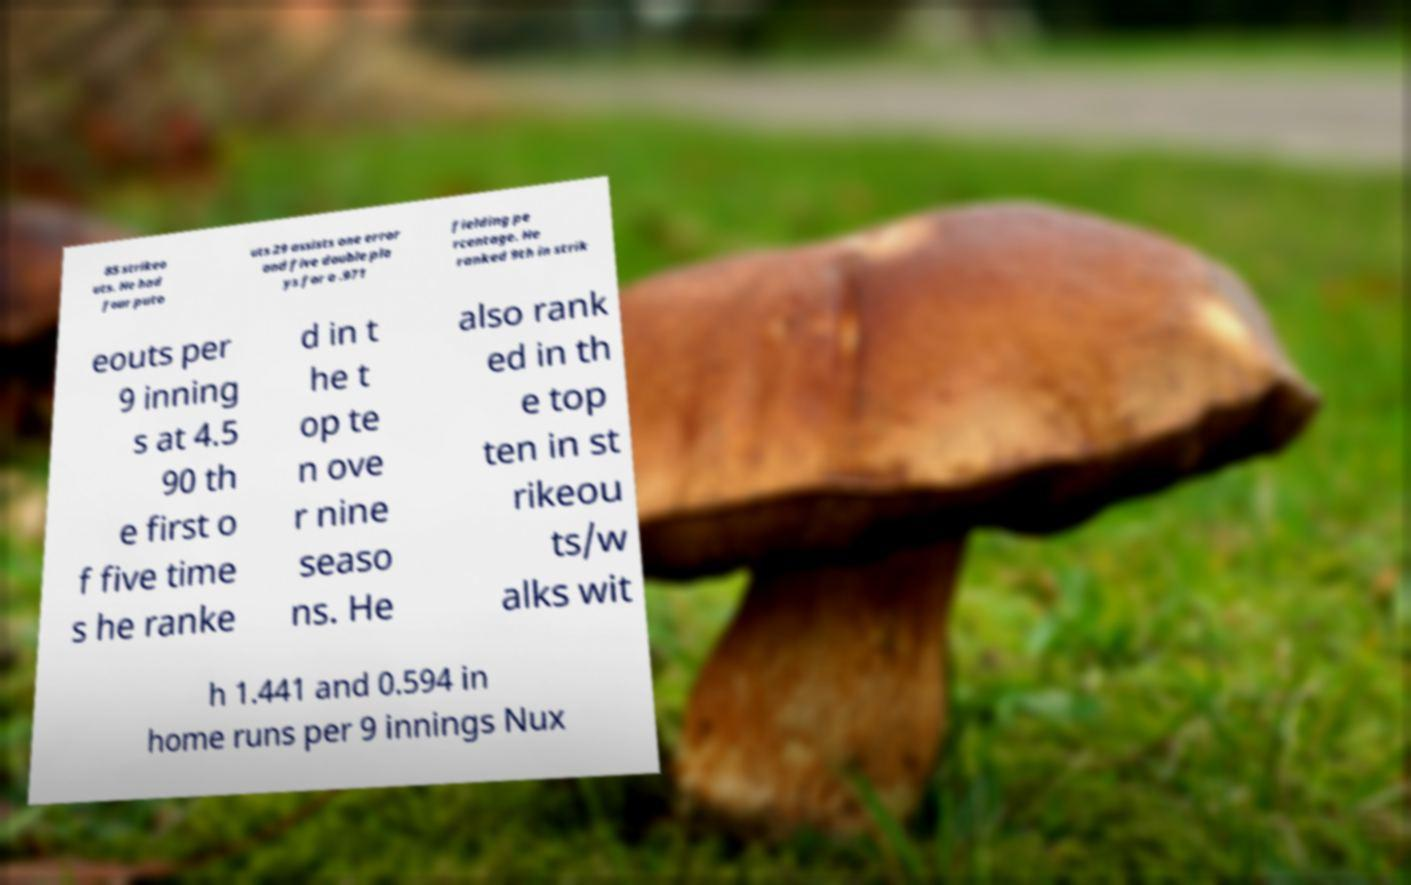For documentation purposes, I need the text within this image transcribed. Could you provide that? 85 strikeo uts. He had four puto uts 29 assists one error and five double pla ys for a .971 fielding pe rcentage. He ranked 9th in strik eouts per 9 inning s at 4.5 90 th e first o f five time s he ranke d in t he t op te n ove r nine seaso ns. He also rank ed in th e top ten in st rikeou ts/w alks wit h 1.441 and 0.594 in home runs per 9 innings Nux 